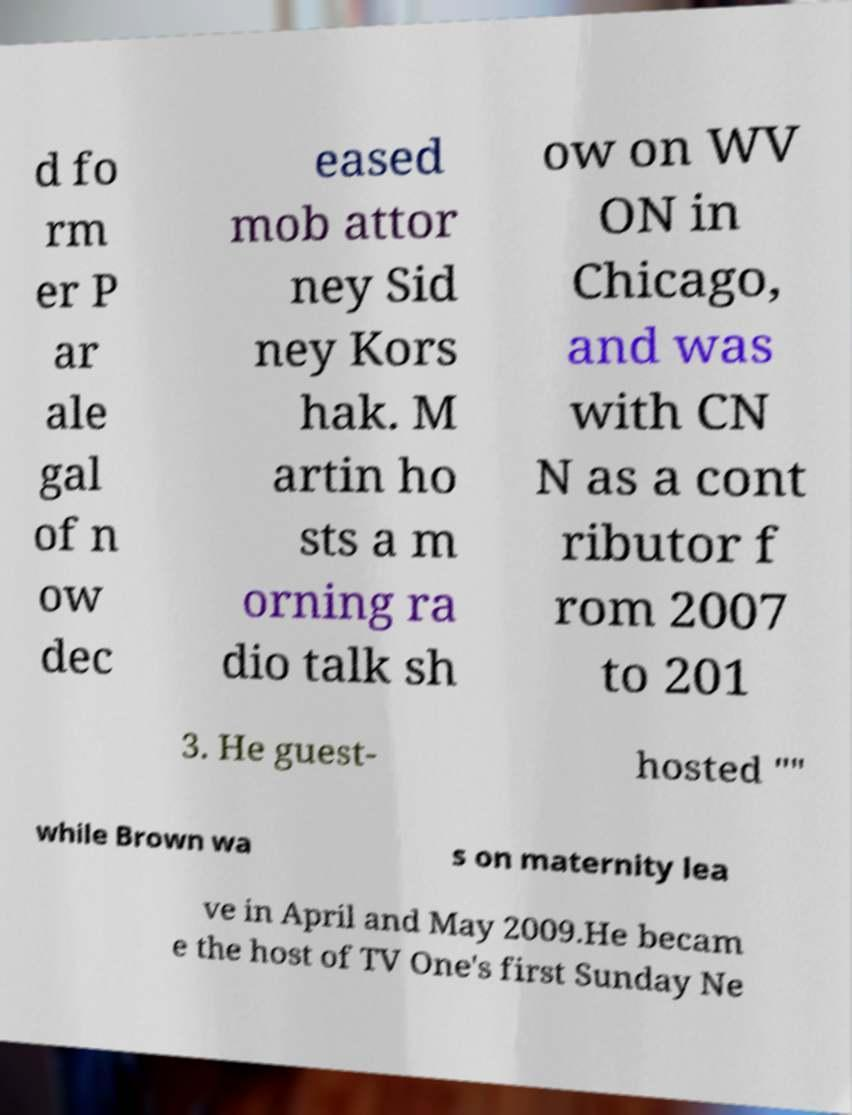Could you assist in decoding the text presented in this image and type it out clearly? d fo rm er P ar ale gal of n ow dec eased mob attor ney Sid ney Kors hak. M artin ho sts a m orning ra dio talk sh ow on WV ON in Chicago, and was with CN N as a cont ributor f rom 2007 to 201 3. He guest- hosted "" while Brown wa s on maternity lea ve in April and May 2009.He becam e the host of TV One's first Sunday Ne 